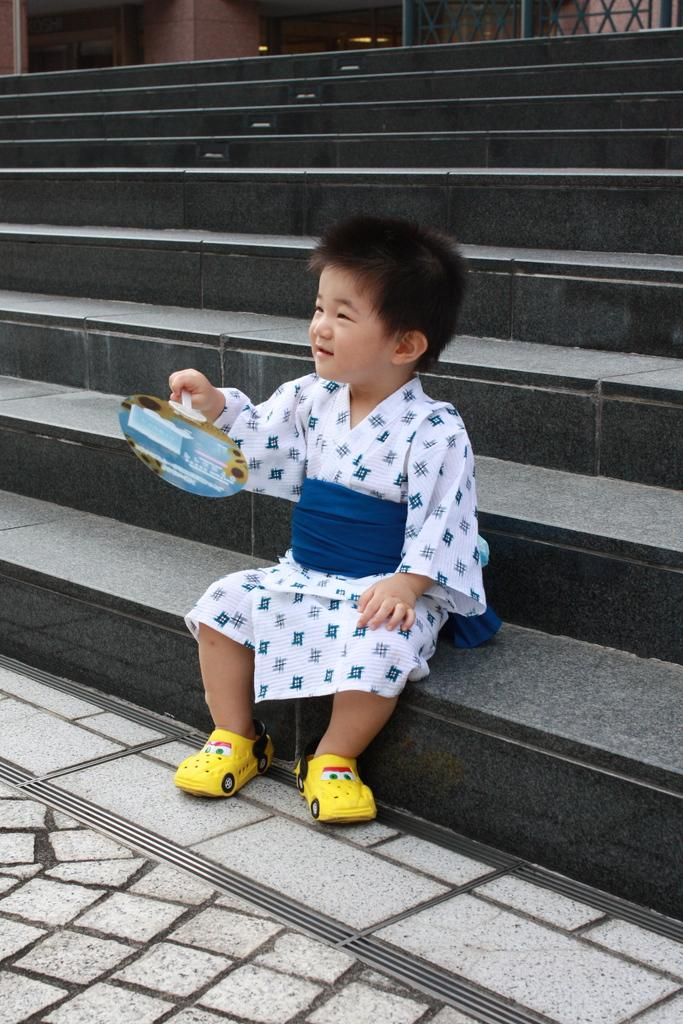What is the main subject of the image? The main subject of the image is a kid. Where is the kid located in the image? The kid is sitting on the stairs of a building. What is the kid holding in his hand? The kid is holding an object in his hand. Can you tell me how many rivers are visible in the image? There are no rivers visible in the image. What type of thing is the kid holding in his hand? The provided facts do not specify the type of object the kid is holding in his hand. Is the kid using a calculator in the image? There is no mention of a calculator in the image. 